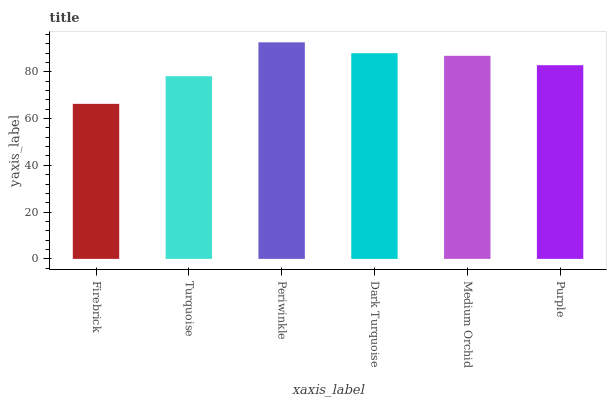Is Firebrick the minimum?
Answer yes or no. Yes. Is Periwinkle the maximum?
Answer yes or no. Yes. Is Turquoise the minimum?
Answer yes or no. No. Is Turquoise the maximum?
Answer yes or no. No. Is Turquoise greater than Firebrick?
Answer yes or no. Yes. Is Firebrick less than Turquoise?
Answer yes or no. Yes. Is Firebrick greater than Turquoise?
Answer yes or no. No. Is Turquoise less than Firebrick?
Answer yes or no. No. Is Medium Orchid the high median?
Answer yes or no. Yes. Is Purple the low median?
Answer yes or no. Yes. Is Firebrick the high median?
Answer yes or no. No. Is Turquoise the low median?
Answer yes or no. No. 